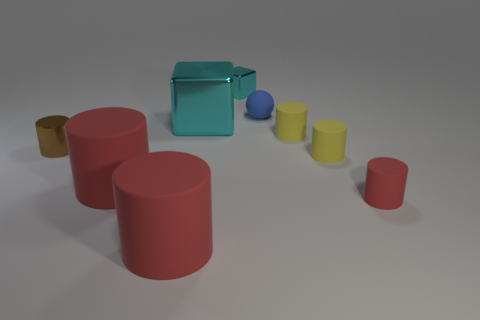Subtract all gray balls. How many red cylinders are left? 3 Subtract all brown cylinders. How many cylinders are left? 5 Subtract 1 cylinders. How many cylinders are left? 5 Subtract all tiny metal cylinders. How many cylinders are left? 5 Subtract all brown cylinders. Subtract all cyan cubes. How many cylinders are left? 5 Add 1 green objects. How many objects exist? 10 Subtract all cylinders. How many objects are left? 3 Subtract all tiny objects. Subtract all brown metallic balls. How many objects are left? 3 Add 7 big shiny objects. How many big shiny objects are left? 8 Add 6 big shiny blocks. How many big shiny blocks exist? 7 